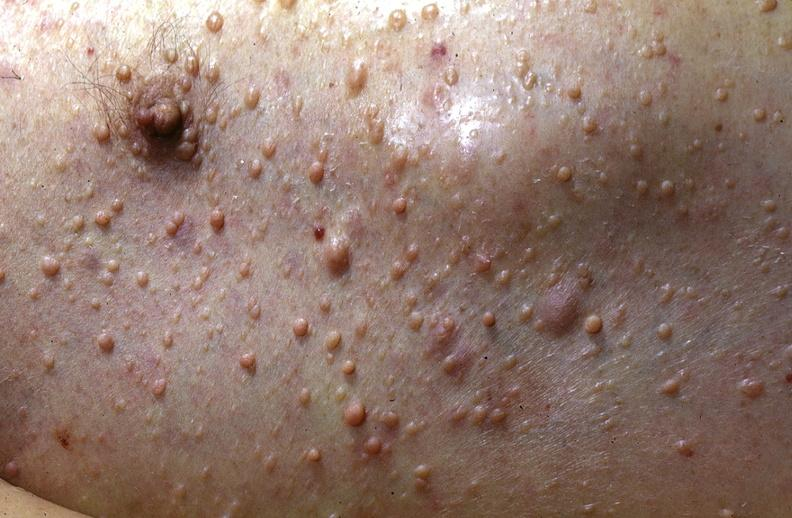where is this?
Answer the question using a single word or phrase. Skin 